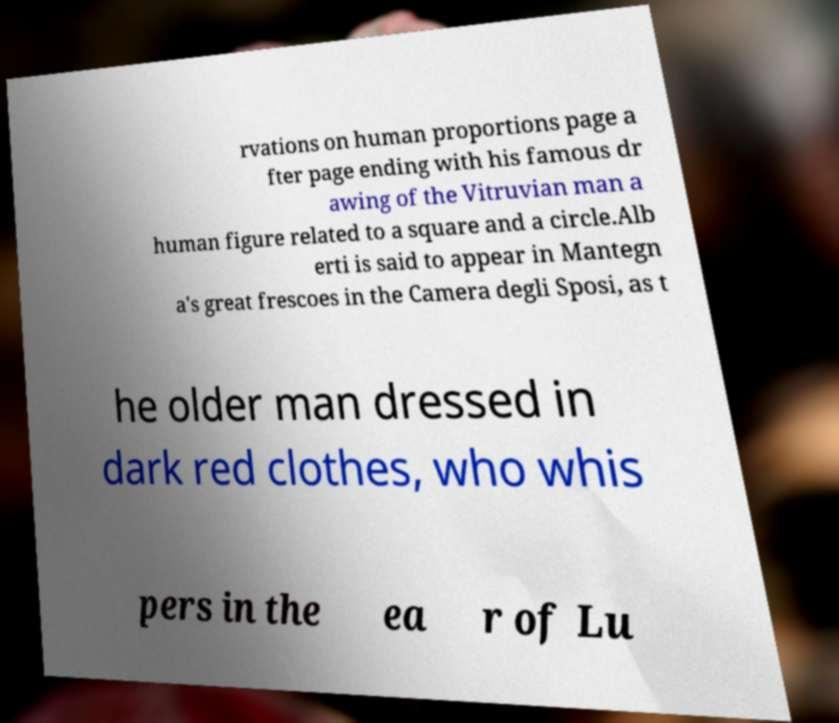Can you accurately transcribe the text from the provided image for me? rvations on human proportions page a fter page ending with his famous dr awing of the Vitruvian man a human figure related to a square and a circle.Alb erti is said to appear in Mantegn a's great frescoes in the Camera degli Sposi, as t he older man dressed in dark red clothes, who whis pers in the ea r of Lu 